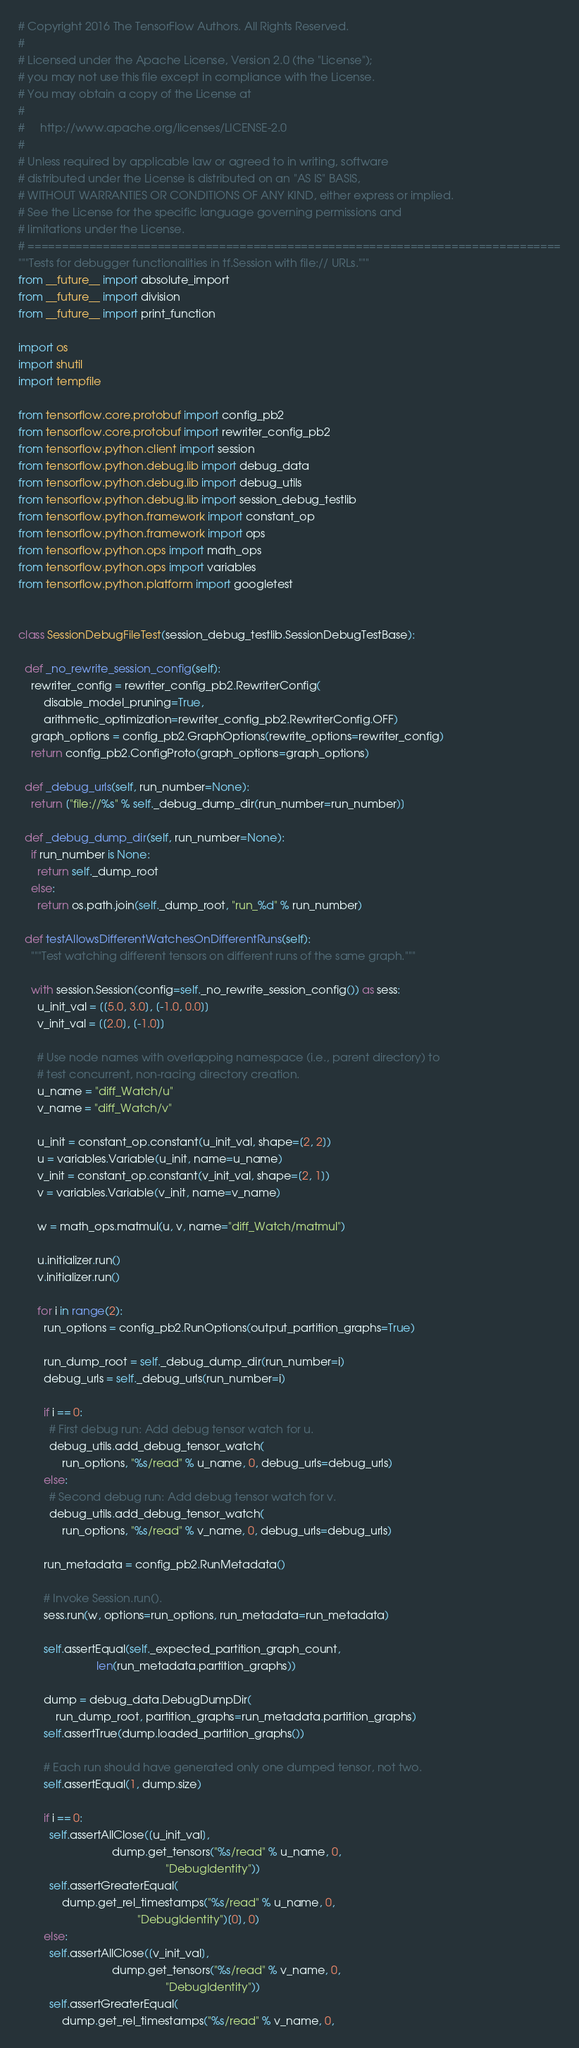Convert code to text. <code><loc_0><loc_0><loc_500><loc_500><_Python_># Copyright 2016 The TensorFlow Authors. All Rights Reserved.
#
# Licensed under the Apache License, Version 2.0 (the "License");
# you may not use this file except in compliance with the License.
# You may obtain a copy of the License at
#
#     http://www.apache.org/licenses/LICENSE-2.0
#
# Unless required by applicable law or agreed to in writing, software
# distributed under the License is distributed on an "AS IS" BASIS,
# WITHOUT WARRANTIES OR CONDITIONS OF ANY KIND, either express or implied.
# See the License for the specific language governing permissions and
# limitations under the License.
# ==============================================================================
"""Tests for debugger functionalities in tf.Session with file:// URLs."""
from __future__ import absolute_import
from __future__ import division
from __future__ import print_function

import os
import shutil
import tempfile

from tensorflow.core.protobuf import config_pb2
from tensorflow.core.protobuf import rewriter_config_pb2
from tensorflow.python.client import session
from tensorflow.python.debug.lib import debug_data
from tensorflow.python.debug.lib import debug_utils
from tensorflow.python.debug.lib import session_debug_testlib
from tensorflow.python.framework import constant_op
from tensorflow.python.framework import ops
from tensorflow.python.ops import math_ops
from tensorflow.python.ops import variables
from tensorflow.python.platform import googletest


class SessionDebugFileTest(session_debug_testlib.SessionDebugTestBase):

  def _no_rewrite_session_config(self):
    rewriter_config = rewriter_config_pb2.RewriterConfig(
        disable_model_pruning=True,
        arithmetic_optimization=rewriter_config_pb2.RewriterConfig.OFF)
    graph_options = config_pb2.GraphOptions(rewrite_options=rewriter_config)
    return config_pb2.ConfigProto(graph_options=graph_options)

  def _debug_urls(self, run_number=None):
    return ["file://%s" % self._debug_dump_dir(run_number=run_number)]

  def _debug_dump_dir(self, run_number=None):
    if run_number is None:
      return self._dump_root
    else:
      return os.path.join(self._dump_root, "run_%d" % run_number)

  def testAllowsDifferentWatchesOnDifferentRuns(self):
    """Test watching different tensors on different runs of the same graph."""

    with session.Session(config=self._no_rewrite_session_config()) as sess:
      u_init_val = [[5.0, 3.0], [-1.0, 0.0]]
      v_init_val = [[2.0], [-1.0]]

      # Use node names with overlapping namespace (i.e., parent directory) to
      # test concurrent, non-racing directory creation.
      u_name = "diff_Watch/u"
      v_name = "diff_Watch/v"

      u_init = constant_op.constant(u_init_val, shape=[2, 2])
      u = variables.Variable(u_init, name=u_name)
      v_init = constant_op.constant(v_init_val, shape=[2, 1])
      v = variables.Variable(v_init, name=v_name)

      w = math_ops.matmul(u, v, name="diff_Watch/matmul")

      u.initializer.run()
      v.initializer.run()

      for i in range(2):
        run_options = config_pb2.RunOptions(output_partition_graphs=True)

        run_dump_root = self._debug_dump_dir(run_number=i)
        debug_urls = self._debug_urls(run_number=i)

        if i == 0:
          # First debug run: Add debug tensor watch for u.
          debug_utils.add_debug_tensor_watch(
              run_options, "%s/read" % u_name, 0, debug_urls=debug_urls)
        else:
          # Second debug run: Add debug tensor watch for v.
          debug_utils.add_debug_tensor_watch(
              run_options, "%s/read" % v_name, 0, debug_urls=debug_urls)

        run_metadata = config_pb2.RunMetadata()

        # Invoke Session.run().
        sess.run(w, options=run_options, run_metadata=run_metadata)

        self.assertEqual(self._expected_partition_graph_count,
                         len(run_metadata.partition_graphs))

        dump = debug_data.DebugDumpDir(
            run_dump_root, partition_graphs=run_metadata.partition_graphs)
        self.assertTrue(dump.loaded_partition_graphs())

        # Each run should have generated only one dumped tensor, not two.
        self.assertEqual(1, dump.size)

        if i == 0:
          self.assertAllClose([u_init_val],
                              dump.get_tensors("%s/read" % u_name, 0,
                                               "DebugIdentity"))
          self.assertGreaterEqual(
              dump.get_rel_timestamps("%s/read" % u_name, 0,
                                      "DebugIdentity")[0], 0)
        else:
          self.assertAllClose([v_init_val],
                              dump.get_tensors("%s/read" % v_name, 0,
                                               "DebugIdentity"))
          self.assertGreaterEqual(
              dump.get_rel_timestamps("%s/read" % v_name, 0,</code> 